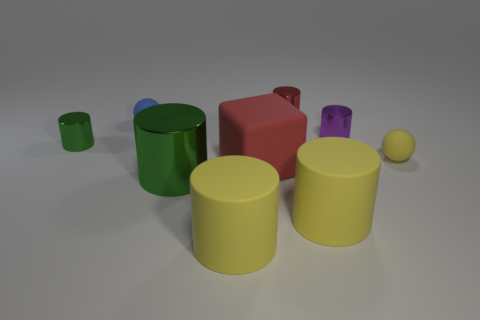How many green cylinders must be subtracted to get 1 green cylinders? 1 Subtract all tiny red cylinders. How many cylinders are left? 5 Subtract all brown blocks. How many green cylinders are left? 2 Subtract all green cylinders. How many cylinders are left? 4 Subtract 1 spheres. How many spheres are left? 1 Subtract all cylinders. How many objects are left? 3 Add 1 tiny green shiny things. How many tiny green shiny things exist? 2 Subtract 0 brown cubes. How many objects are left? 9 Subtract all purple cylinders. Subtract all brown cubes. How many cylinders are left? 5 Subtract all purple metallic objects. Subtract all large things. How many objects are left? 4 